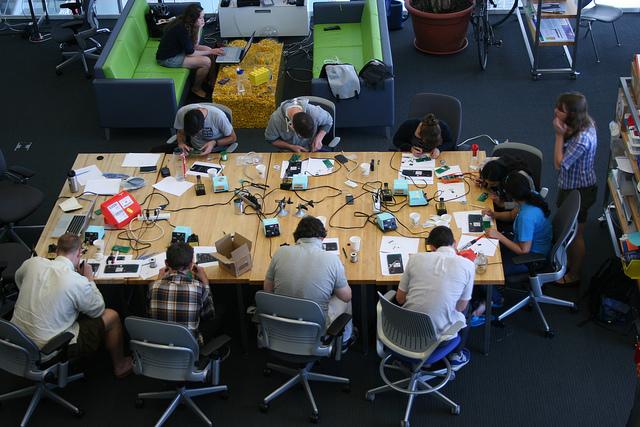Are any of the men looking up?
Be succinct. No. What does this picture have in common?
Write a very short answer. Electronics. How many plants are there?
Be succinct. 0. How many people are sitting down?
Be succinct. 9. 